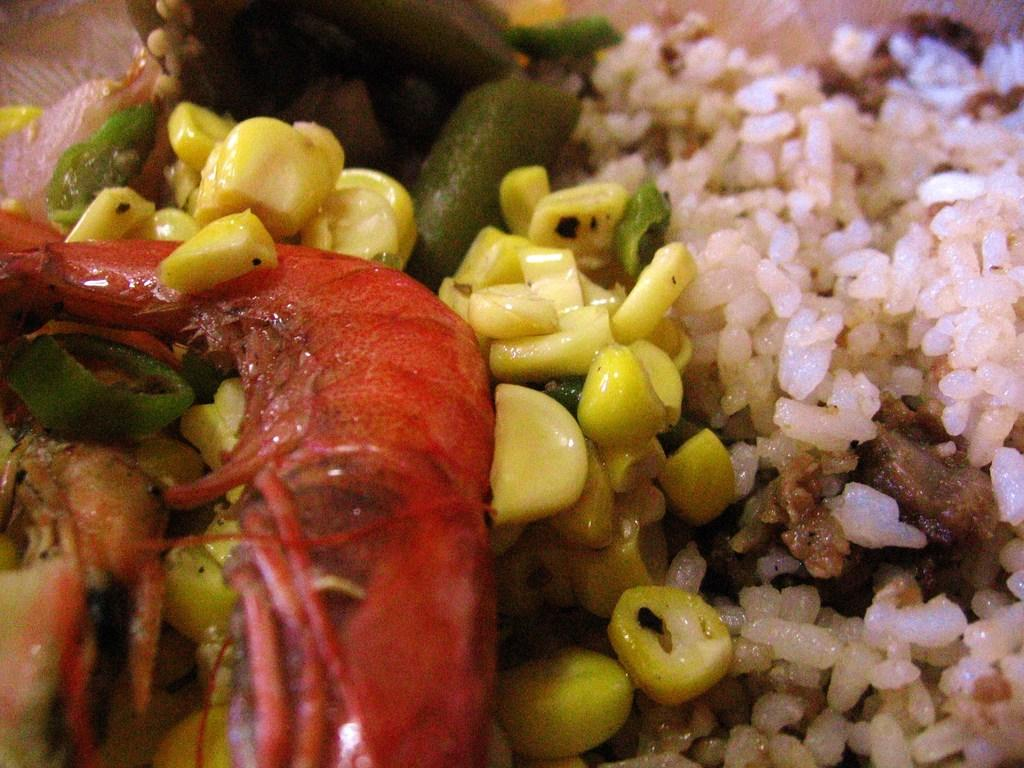What type of food can be seen in the image? There is rice, corn, meat, and vegetables in the image. Can you describe the different components of the dish? The dish contains rice, corn, meat, and various vegetables. What type of button can be seen on the field in the image? There is no button or field present in the image; it features food items such as rice, corn, meat, and vegetables. What type of glass is used to serve the dish in the image? There is no glass present in the image; the food items are not shown in a serving dish or container. 